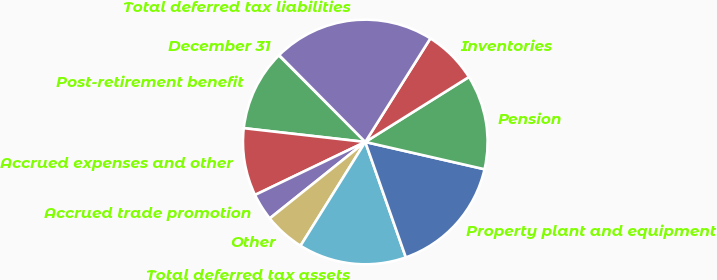<chart> <loc_0><loc_0><loc_500><loc_500><pie_chart><fcel>December 31<fcel>Post-retirement benefit<fcel>Accrued expenses and other<fcel>Accrued trade promotion<fcel>Other<fcel>Total deferred tax assets<fcel>Property plant and equipment<fcel>Pension<fcel>Inventories<fcel>Total deferred tax liabilities<nl><fcel>0.06%<fcel>10.71%<fcel>8.93%<fcel>3.61%<fcel>5.38%<fcel>14.26%<fcel>16.04%<fcel>12.49%<fcel>7.16%<fcel>21.36%<nl></chart> 